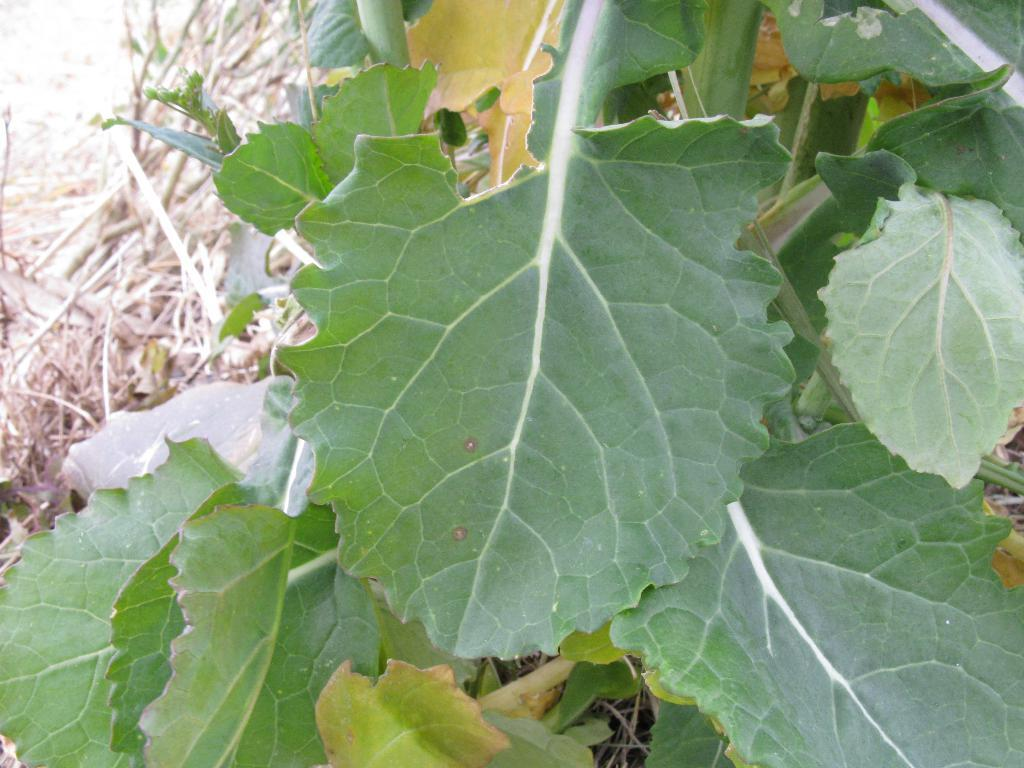What type of plant is present in the image? There is a tree with green leaves in the image. What is the condition of the grass in the image? There is dry grass on the ground in the image. Where is the shop located in the image? There is no shop present in the image. Can you see someone kicking the tree in the image? There is no person or action of kicking in the image. 